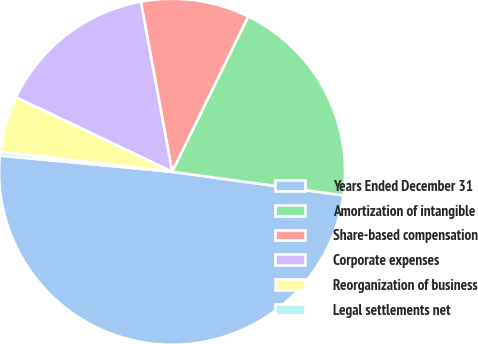Convert chart. <chart><loc_0><loc_0><loc_500><loc_500><pie_chart><fcel>Years Ended December 31<fcel>Amortization of intangible<fcel>Share-based compensation<fcel>Corporate expenses<fcel>Reorganization of business<fcel>Legal settlements net<nl><fcel>49.31%<fcel>19.93%<fcel>10.14%<fcel>15.03%<fcel>5.24%<fcel>0.34%<nl></chart> 